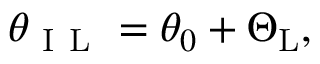Convert formula to latex. <formula><loc_0><loc_0><loc_500><loc_500>\theta _ { I L } = \theta _ { 0 } + \Theta _ { L } ,</formula> 